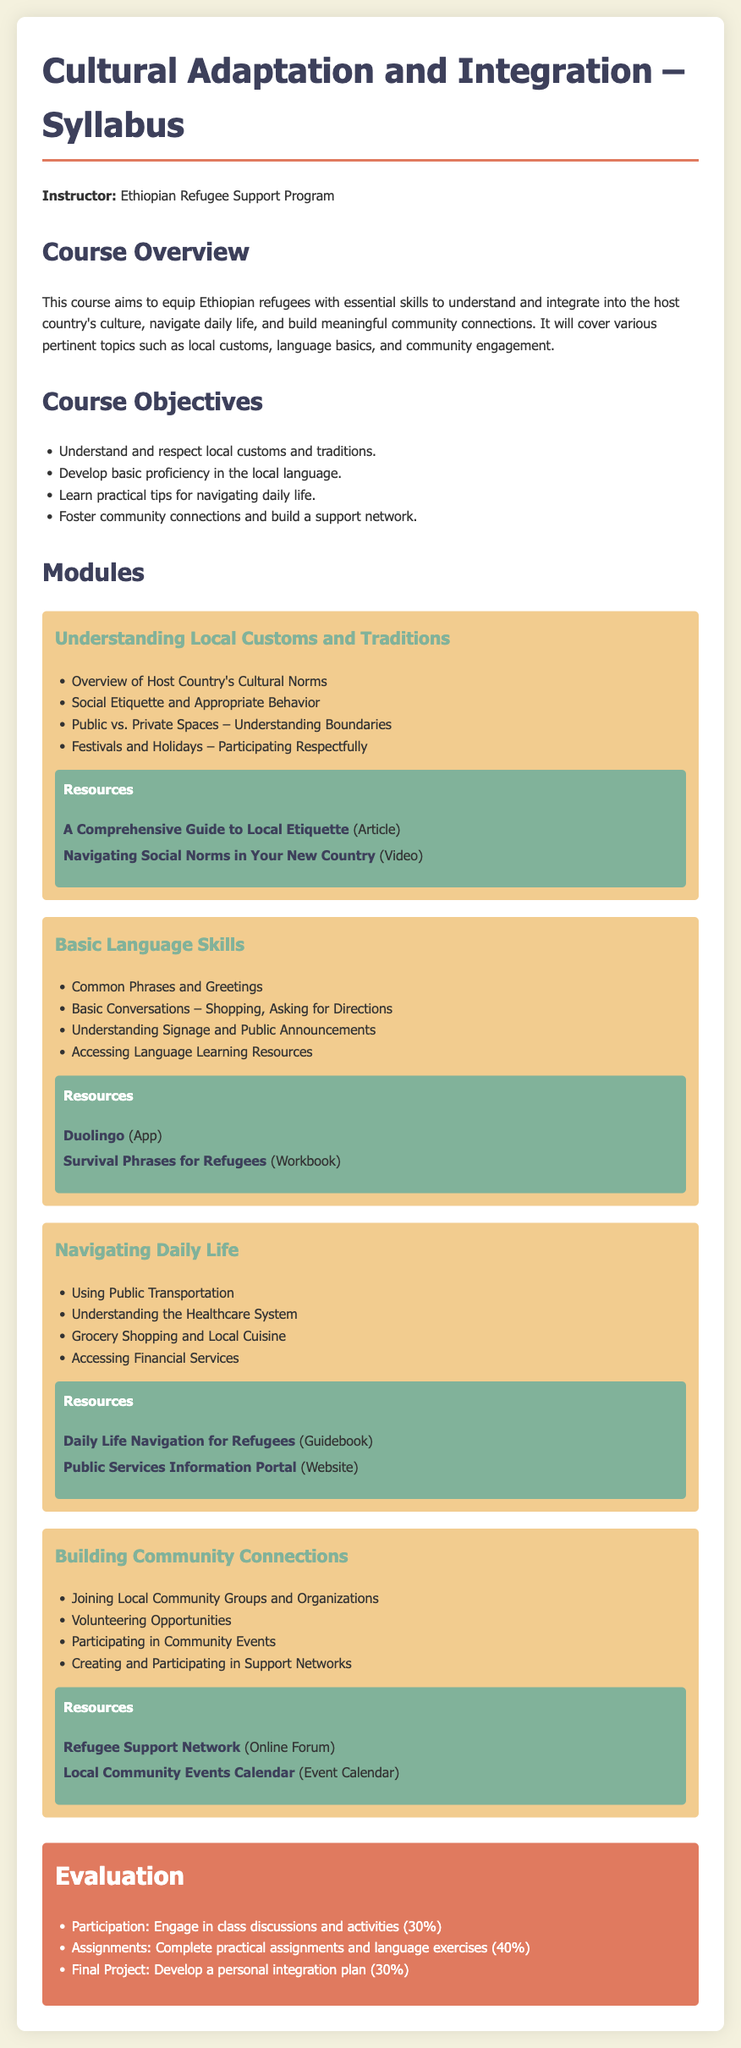what is the name of the instructor? The instructor of the course is mentioned as the Ethiopian Refugee Support Program.
Answer: Ethiopian Refugee Support Program what is the main focus of the course? The course aims to equip Ethiopian refugees with essential skills to understand and integrate into the host country's culture.
Answer: Cultural adaptation and integration how many course objectives are listed? The document lists four course objectives.
Answer: 4 what is the first module title? The first module listed in the syllabus is "Understanding Local Customs and Traditions."
Answer: Understanding Local Customs and Traditions which platform offers a language learning app? The document mentions Duolingo as a language learning app.
Answer: Duolingo what percentage is assigned to participation in the evaluation? Participation accounts for 30% of the overall evaluation in the syllabus.
Answer: 30% what type of opportunities are included in the "Building Community Connections" module? The module includes "Volunteering Opportunities" among other activities.
Answer: Volunteering Opportunities what is one way to access financial services mentioned in the syllabus? The syllabus suggests understanding the healthcare system as a way to navigate daily life, indirectly related to financial services.
Answer: Understanding the Healthcare System 